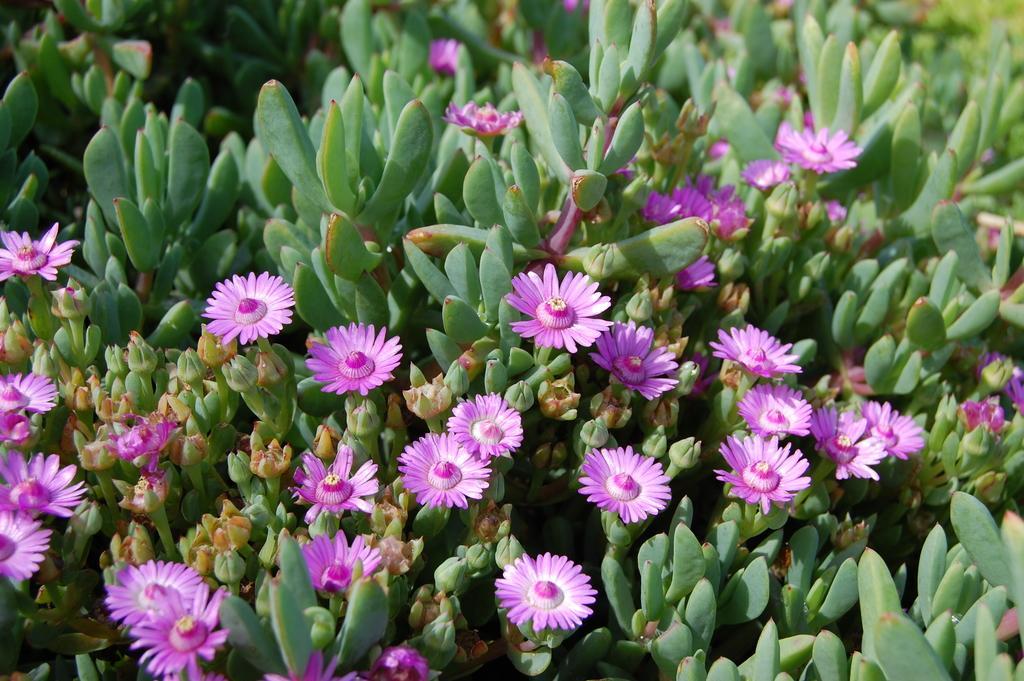Describe this image in one or two sentences. In this image we can see flowers, buds, and leaves. 